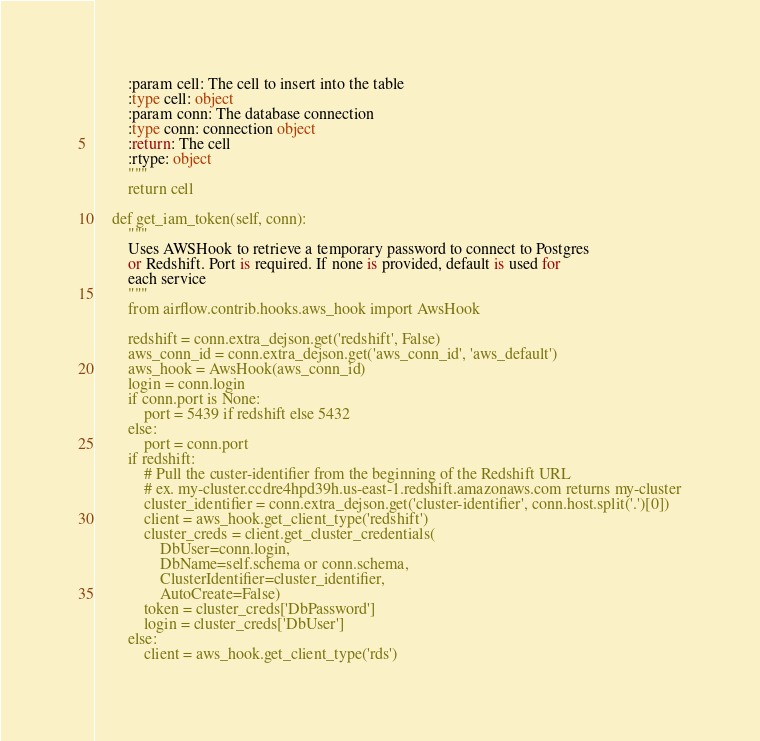Convert code to text. <code><loc_0><loc_0><loc_500><loc_500><_Python_>        :param cell: The cell to insert into the table
        :type cell: object
        :param conn: The database connection
        :type conn: connection object
        :return: The cell
        :rtype: object
        """
        return cell

    def get_iam_token(self, conn):
        """
        Uses AWSHook to retrieve a temporary password to connect to Postgres
        or Redshift. Port is required. If none is provided, default is used for
        each service
        """
        from airflow.contrib.hooks.aws_hook import AwsHook

        redshift = conn.extra_dejson.get('redshift', False)
        aws_conn_id = conn.extra_dejson.get('aws_conn_id', 'aws_default')
        aws_hook = AwsHook(aws_conn_id)
        login = conn.login
        if conn.port is None:
            port = 5439 if redshift else 5432
        else:
            port = conn.port
        if redshift:
            # Pull the custer-identifier from the beginning of the Redshift URL
            # ex. my-cluster.ccdre4hpd39h.us-east-1.redshift.amazonaws.com returns my-cluster
            cluster_identifier = conn.extra_dejson.get('cluster-identifier', conn.host.split('.')[0])
            client = aws_hook.get_client_type('redshift')
            cluster_creds = client.get_cluster_credentials(
                DbUser=conn.login,
                DbName=self.schema or conn.schema,
                ClusterIdentifier=cluster_identifier,
                AutoCreate=False)
            token = cluster_creds['DbPassword']
            login = cluster_creds['DbUser']
        else:
            client = aws_hook.get_client_type('rds')</code> 